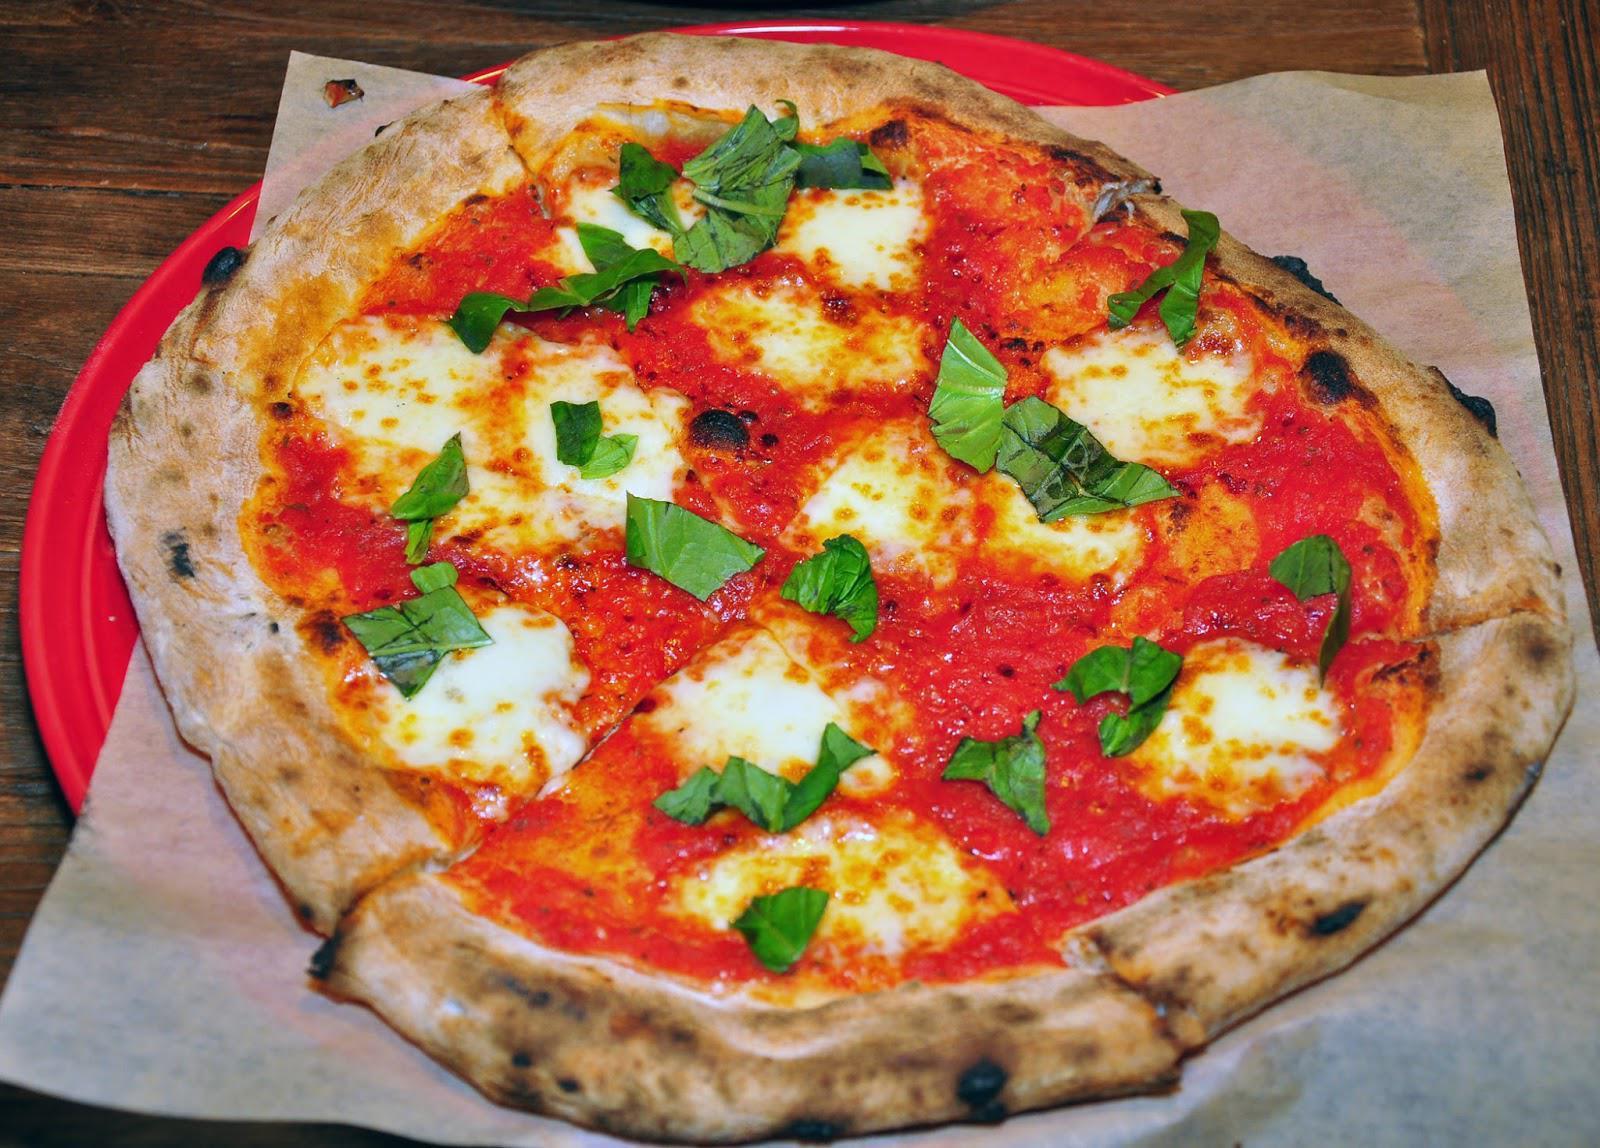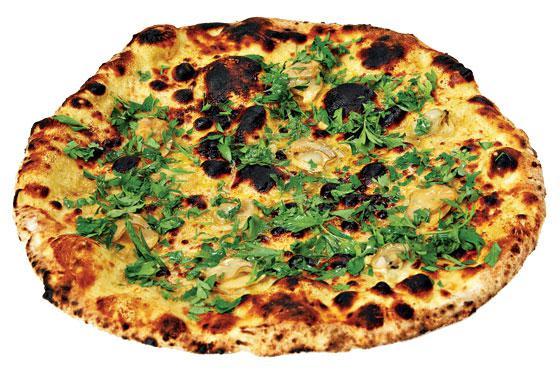The first image is the image on the left, the second image is the image on the right. Given the left and right images, does the statement "A whole cooked pizza is on a white plate." hold true? Answer yes or no. No. The first image is the image on the left, the second image is the image on the right. Considering the images on both sides, is "In at least one image the is a small piece of pizza with toppings sit on top of a circle white plate." valid? Answer yes or no. No. 